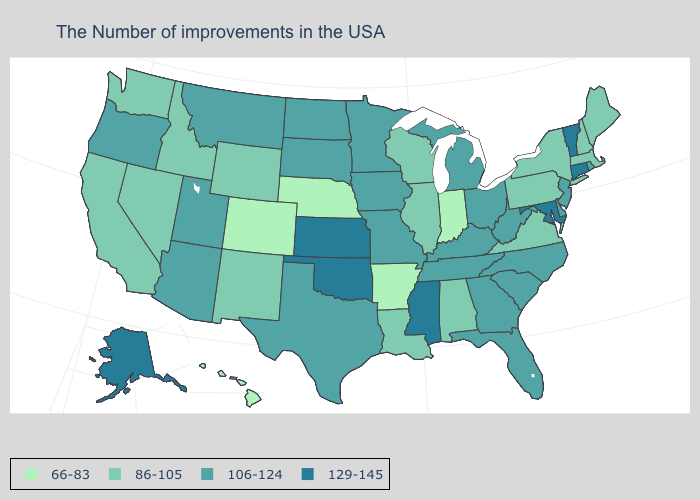Which states have the highest value in the USA?
Short answer required. Vermont, Connecticut, Maryland, Mississippi, Kansas, Oklahoma, Alaska. What is the value of Alabama?
Answer briefly. 86-105. How many symbols are there in the legend?
Concise answer only. 4. Which states have the lowest value in the USA?
Keep it brief. Indiana, Arkansas, Nebraska, Colorado, Hawaii. What is the highest value in the USA?
Concise answer only. 129-145. Does Ohio have the highest value in the USA?
Be succinct. No. Among the states that border California , which have the highest value?
Short answer required. Arizona, Oregon. Does South Dakota have the same value as Rhode Island?
Be succinct. Yes. Among the states that border Georgia , does Alabama have the highest value?
Be succinct. No. Does the map have missing data?
Concise answer only. No. Name the states that have a value in the range 86-105?
Concise answer only. Maine, Massachusetts, New Hampshire, New York, Pennsylvania, Virginia, Alabama, Wisconsin, Illinois, Louisiana, Wyoming, New Mexico, Idaho, Nevada, California, Washington. What is the value of Michigan?
Short answer required. 106-124. Among the states that border Ohio , does Indiana have the lowest value?
Write a very short answer. Yes. What is the value of Florida?
Quick response, please. 106-124. How many symbols are there in the legend?
Keep it brief. 4. 